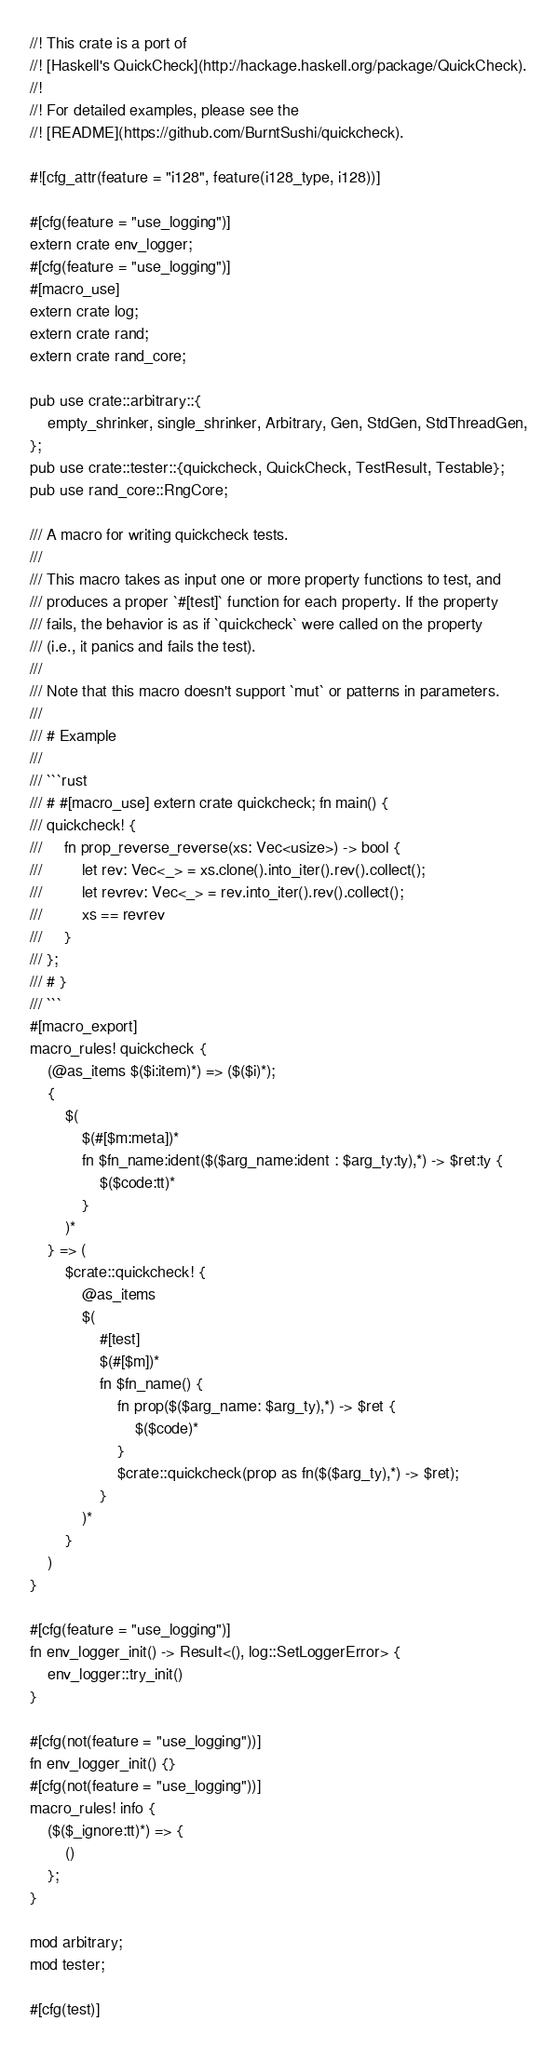Convert code to text. <code><loc_0><loc_0><loc_500><loc_500><_Rust_>//! This crate is a port of
//! [Haskell's QuickCheck](http://hackage.haskell.org/package/QuickCheck).
//!
//! For detailed examples, please see the
//! [README](https://github.com/BurntSushi/quickcheck).

#![cfg_attr(feature = "i128", feature(i128_type, i128))]

#[cfg(feature = "use_logging")]
extern crate env_logger;
#[cfg(feature = "use_logging")]
#[macro_use]
extern crate log;
extern crate rand;
extern crate rand_core;

pub use crate::arbitrary::{
    empty_shrinker, single_shrinker, Arbitrary, Gen, StdGen, StdThreadGen,
};
pub use crate::tester::{quickcheck, QuickCheck, TestResult, Testable};
pub use rand_core::RngCore;

/// A macro for writing quickcheck tests.
///
/// This macro takes as input one or more property functions to test, and
/// produces a proper `#[test]` function for each property. If the property
/// fails, the behavior is as if `quickcheck` were called on the property
/// (i.e., it panics and fails the test).
///
/// Note that this macro doesn't support `mut` or patterns in parameters.
///
/// # Example
///
/// ```rust
/// # #[macro_use] extern crate quickcheck; fn main() {
/// quickcheck! {
///     fn prop_reverse_reverse(xs: Vec<usize>) -> bool {
///         let rev: Vec<_> = xs.clone().into_iter().rev().collect();
///         let revrev: Vec<_> = rev.into_iter().rev().collect();
///         xs == revrev
///     }
/// };
/// # }
/// ```
#[macro_export]
macro_rules! quickcheck {
    (@as_items $($i:item)*) => ($($i)*);
    {
        $(
            $(#[$m:meta])*
            fn $fn_name:ident($($arg_name:ident : $arg_ty:ty),*) -> $ret:ty {
                $($code:tt)*
            }
        )*
    } => (
        $crate::quickcheck! {
            @as_items
            $(
                #[test]
                $(#[$m])*
                fn $fn_name() {
                    fn prop($($arg_name: $arg_ty),*) -> $ret {
                        $($code)*
                    }
                    $crate::quickcheck(prop as fn($($arg_ty),*) -> $ret);
                }
            )*
        }
    )
}

#[cfg(feature = "use_logging")]
fn env_logger_init() -> Result<(), log::SetLoggerError> {
    env_logger::try_init()
}

#[cfg(not(feature = "use_logging"))]
fn env_logger_init() {}
#[cfg(not(feature = "use_logging"))]
macro_rules! info {
    ($($_ignore:tt)*) => {
        ()
    };
}

mod arbitrary;
mod tester;

#[cfg(test)]</code> 